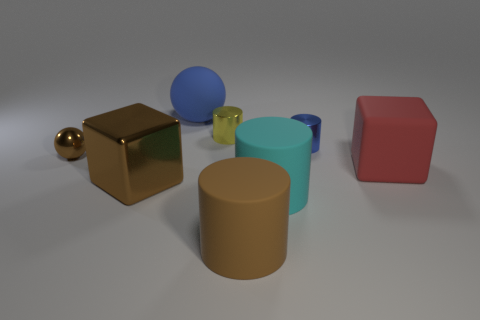Are there fewer yellow cylinders that are in front of the large cyan object than things to the right of the blue matte object?
Provide a short and direct response. Yes. There is a metallic thing that is behind the blue metallic cylinder; is it the same size as the cyan matte cylinder?
Your response must be concise. No. There is a large brown object that is to the right of the large rubber ball; what shape is it?
Provide a short and direct response. Cylinder. Is the number of big rubber cylinders greater than the number of tiny brown things?
Provide a succinct answer. Yes. Do the shiny object right of the big brown rubber thing and the big matte cube have the same color?
Provide a succinct answer. No. What number of things are either blue things to the left of the big cyan matte cylinder or big rubber things in front of the large brown block?
Your answer should be compact. 3. What number of shiny things are both in front of the large red thing and behind the small brown ball?
Offer a terse response. 0. Are the big brown cube and the large red block made of the same material?
Your answer should be compact. No. There is a shiny thing that is left of the big brown metallic cube on the left side of the block that is on the right side of the rubber sphere; what shape is it?
Offer a terse response. Sphere. There is a big object that is both on the right side of the big blue matte object and behind the large cyan object; what is it made of?
Offer a terse response. Rubber. 